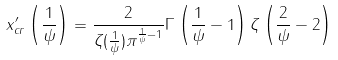<formula> <loc_0><loc_0><loc_500><loc_500>x ^ { \prime } _ { c r } \left ( \frac { 1 } { \psi } \right ) = \frac { 2 } { \zeta ( \frac { 1 } { \psi } ) \pi ^ { \frac { 1 } { \psi } - 1 } } \Gamma \left ( \frac { 1 } { \psi } - 1 \right ) \zeta \left ( \frac { 2 } { \psi } - 2 \right )</formula> 